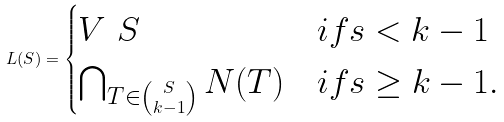Convert formula to latex. <formula><loc_0><loc_0><loc_500><loc_500>L ( S ) = \begin{cases} V \ S & i f s < k - 1 \\ \bigcap _ { T \in \binom { S } { k - 1 } } N ( T ) & i f s \geq k - 1 . \end{cases}</formula> 